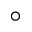<formula> <loc_0><loc_0><loc_500><loc_500>^ { \circ }</formula> 